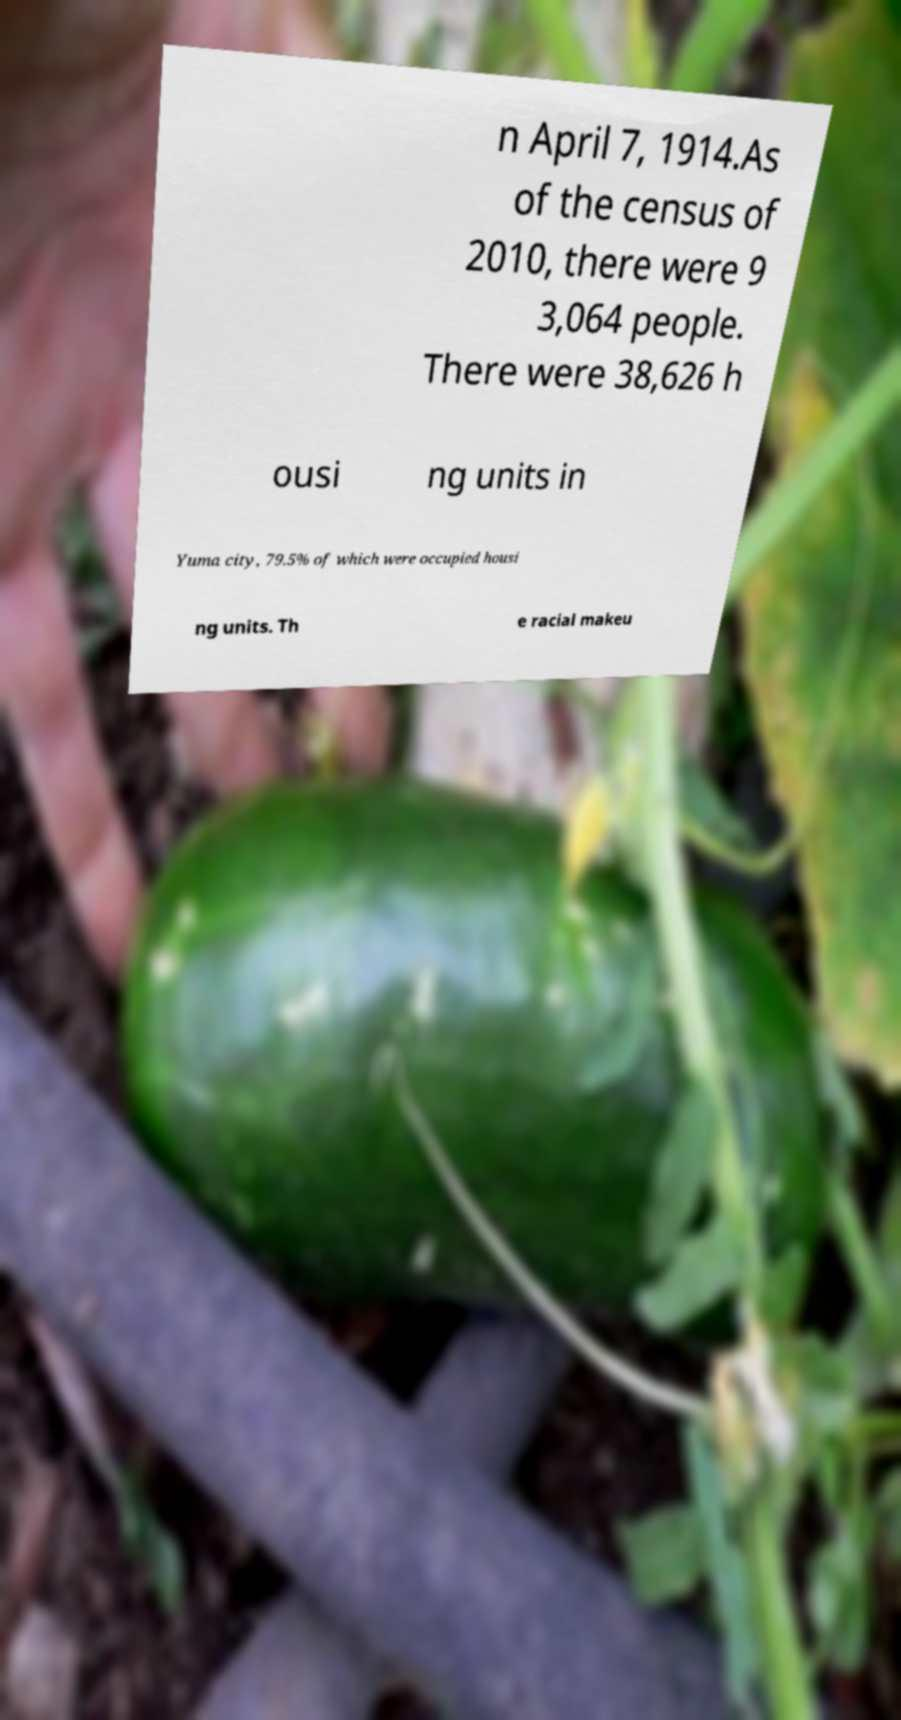Please identify and transcribe the text found in this image. n April 7, 1914.As of the census of 2010, there were 9 3,064 people. There were 38,626 h ousi ng units in Yuma city, 79.5% of which were occupied housi ng units. Th e racial makeu 